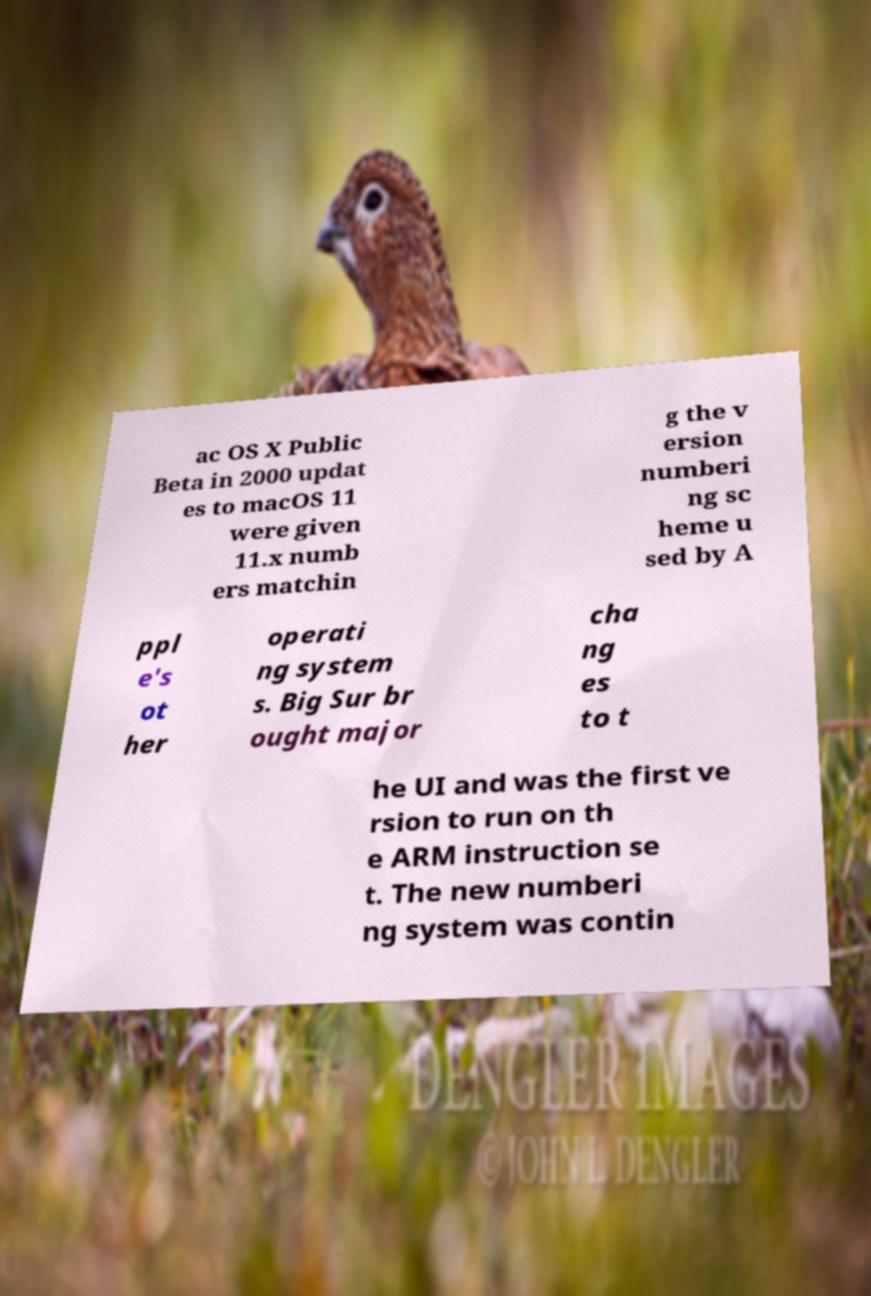Can you accurately transcribe the text from the provided image for me? ac OS X Public Beta in 2000 updat es to macOS 11 were given 11.x numb ers matchin g the v ersion numberi ng sc heme u sed by A ppl e's ot her operati ng system s. Big Sur br ought major cha ng es to t he UI and was the first ve rsion to run on th e ARM instruction se t. The new numberi ng system was contin 